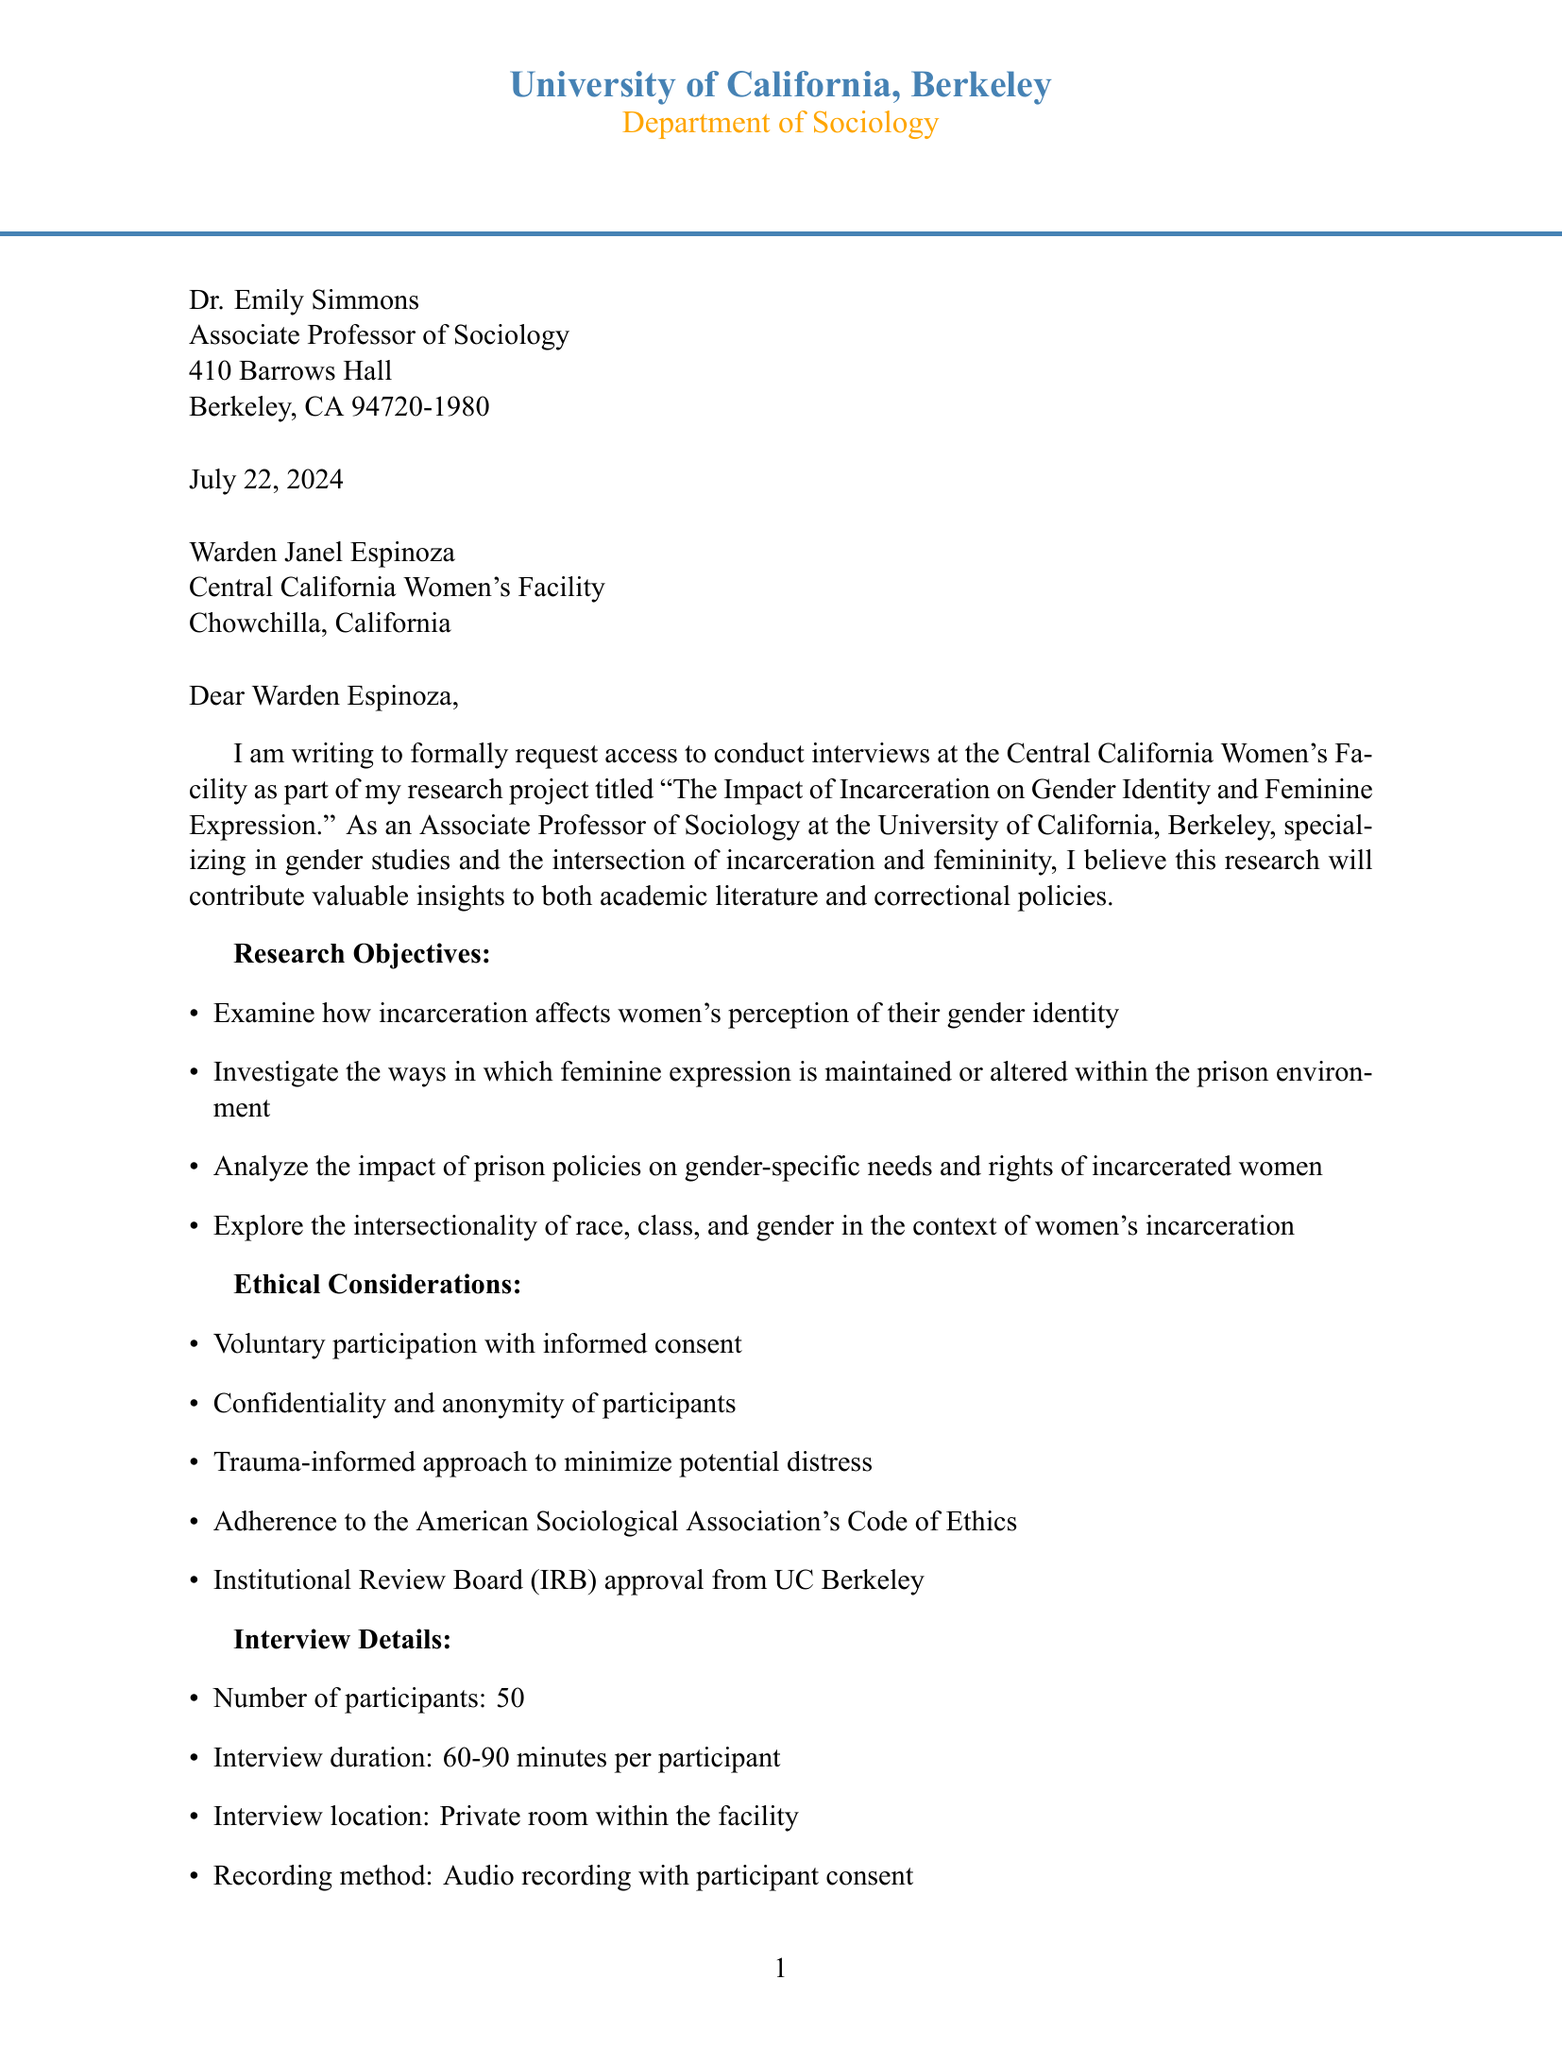What is the name of the researcher? The researcher's name is stated at the beginning of the document as Dr. Emily Simmons.
Answer: Dr. Emily Simmons What is the title of the research project? The title of the research project is clearly mentioned in the letter.
Answer: The Impact of Incarceration on Gender Identity and Feminine Expression How long is the research project expected to last? The duration of the research project is outlined in the document.
Answer: 6 months What type of ethics approval has been obtained for the study? The document specifies adherence to the American Sociological Association's Code of Ethics and mentions an approval from a specific board.
Answer: Institutional Review Board (IRB) How many participants will be interviewed? The number of participants is listed in the interview details of the letter.
Answer: 50 What is one potential benefit of the research? The document enumerates several potential benefits in a section dedicated to this topic.
Answer: Improved understanding of incarcerated women's experiences What should the facility provide for the researcher? The document outlines specific requirements from the facility for conducting the interviews.
Answer: Escort for the researcher within the facility What method will be used to record the interviews? The document explains the method for recording the interviews under interview details.
Answer: Audio recording with participant consent What is the funding source for the research project? The funding source for the research is mentioned in the closing paragraphs of the document.
Answer: National Science Foundation (NSF) Grant 